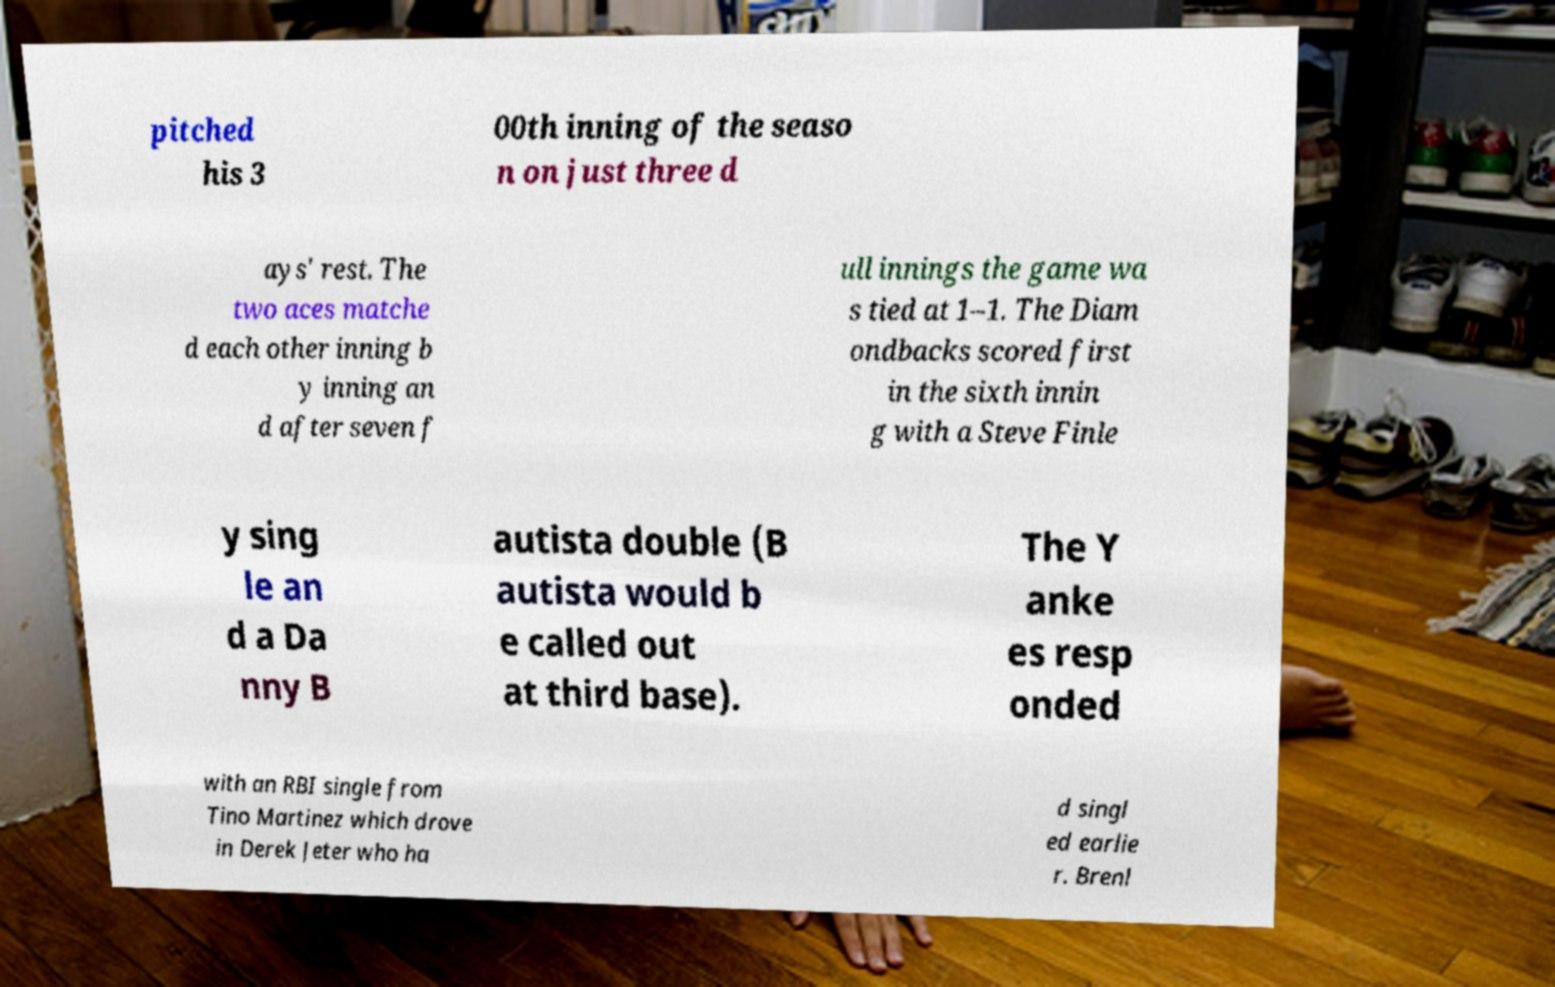I need the written content from this picture converted into text. Can you do that? pitched his 3 00th inning of the seaso n on just three d ays' rest. The two aces matche d each other inning b y inning an d after seven f ull innings the game wa s tied at 1–1. The Diam ondbacks scored first in the sixth innin g with a Steve Finle y sing le an d a Da nny B autista double (B autista would b e called out at third base). The Y anke es resp onded with an RBI single from Tino Martinez which drove in Derek Jeter who ha d singl ed earlie r. Brenl 